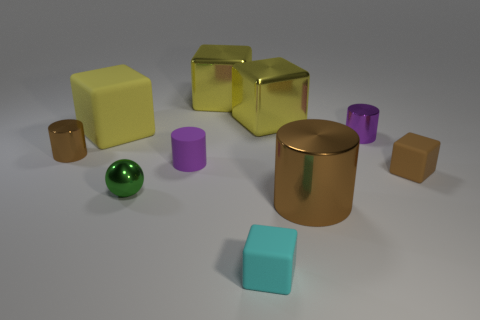How many yellow blocks must be subtracted to get 1 yellow blocks? 2 Subtract all small brown matte blocks. How many blocks are left? 4 Subtract all brown cylinders. How many cylinders are left? 2 Subtract all yellow blocks. How many purple cylinders are left? 2 Subtract all balls. How many objects are left? 9 Subtract 0 red balls. How many objects are left? 10 Subtract 1 cubes. How many cubes are left? 4 Subtract all yellow balls. Subtract all gray blocks. How many balls are left? 1 Subtract all tiny brown matte cubes. Subtract all small green metallic things. How many objects are left? 8 Add 2 large cylinders. How many large cylinders are left? 3 